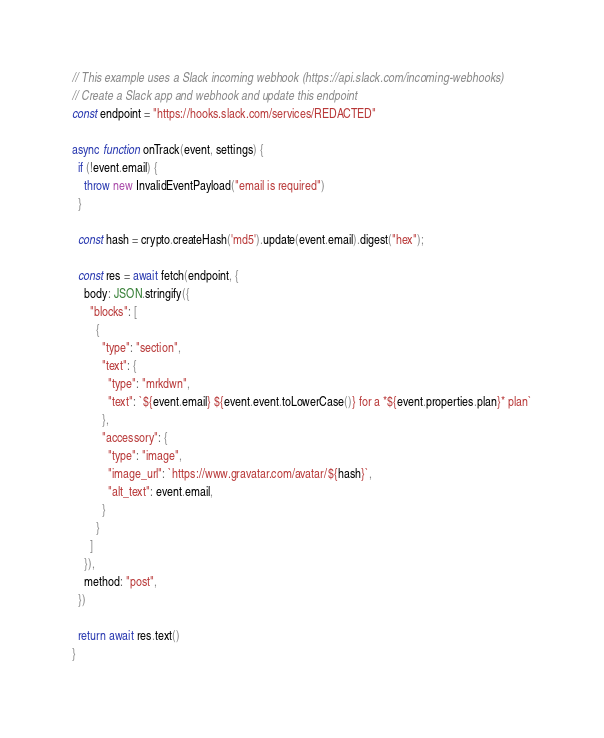<code> <loc_0><loc_0><loc_500><loc_500><_JavaScript_>// This example uses a Slack incoming webhook (https://api.slack.com/incoming-webhooks)
// Create a Slack app and webhook and update this endpoint
const endpoint = "https://hooks.slack.com/services/REDACTED"

async function onTrack(event, settings) {
  if (!event.email) {
    throw new InvalidEventPayload("email is required")
  }

  const hash = crypto.createHash('md5').update(event.email).digest("hex");

  const res = await fetch(endpoint, {
    body: JSON.stringify({
      "blocks": [
        {
          "type": "section",
          "text": {
            "type": "mrkdwn",
            "text": `${event.email} ${event.event.toLowerCase()} for a *${event.properties.plan}* plan`
          },
          "accessory": {
            "type": "image",
            "image_url": `https://www.gravatar.com/avatar/${hash}`,
            "alt_text": event.email,
          }
        }
      ]
    }),
    method: "post",
  })

  return await res.text()
}
</code> 